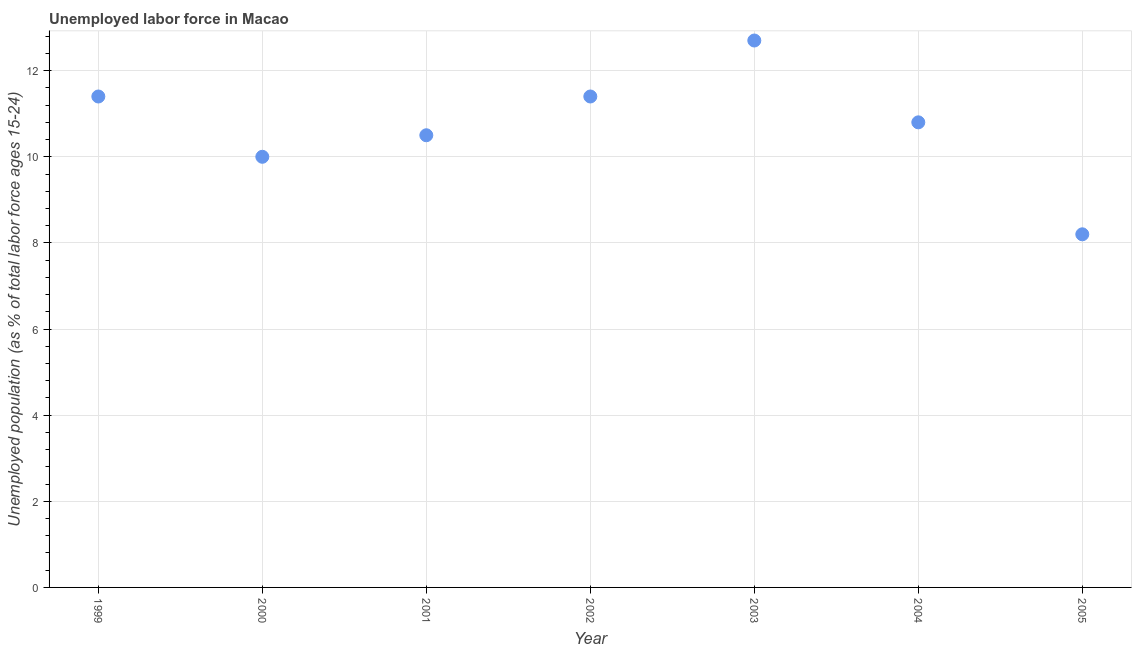What is the total unemployed youth population in 2003?
Offer a terse response. 12.7. Across all years, what is the maximum total unemployed youth population?
Give a very brief answer. 12.7. Across all years, what is the minimum total unemployed youth population?
Your response must be concise. 8.2. What is the sum of the total unemployed youth population?
Your answer should be compact. 75. What is the difference between the total unemployed youth population in 2001 and 2004?
Offer a terse response. -0.3. What is the average total unemployed youth population per year?
Give a very brief answer. 10.71. What is the median total unemployed youth population?
Offer a very short reply. 10.8. Do a majority of the years between 2005 and 2002 (inclusive) have total unemployed youth population greater than 1.2000000000000002 %?
Your answer should be compact. Yes. What is the ratio of the total unemployed youth population in 2003 to that in 2005?
Offer a terse response. 1.55. Is the total unemployed youth population in 1999 less than that in 2000?
Your answer should be compact. No. Is the difference between the total unemployed youth population in 2002 and 2003 greater than the difference between any two years?
Offer a terse response. No. What is the difference between the highest and the second highest total unemployed youth population?
Give a very brief answer. 1.3. Is the sum of the total unemployed youth population in 2000 and 2005 greater than the maximum total unemployed youth population across all years?
Offer a very short reply. Yes. What is the difference between the highest and the lowest total unemployed youth population?
Keep it short and to the point. 4.5. In how many years, is the total unemployed youth population greater than the average total unemployed youth population taken over all years?
Offer a terse response. 4. Does the total unemployed youth population monotonically increase over the years?
Your answer should be very brief. No. How many dotlines are there?
Make the answer very short. 1. What is the difference between two consecutive major ticks on the Y-axis?
Give a very brief answer. 2. Are the values on the major ticks of Y-axis written in scientific E-notation?
Provide a short and direct response. No. What is the title of the graph?
Your answer should be compact. Unemployed labor force in Macao. What is the label or title of the Y-axis?
Provide a short and direct response. Unemployed population (as % of total labor force ages 15-24). What is the Unemployed population (as % of total labor force ages 15-24) in 1999?
Keep it short and to the point. 11.4. What is the Unemployed population (as % of total labor force ages 15-24) in 2001?
Make the answer very short. 10.5. What is the Unemployed population (as % of total labor force ages 15-24) in 2002?
Provide a short and direct response. 11.4. What is the Unemployed population (as % of total labor force ages 15-24) in 2003?
Keep it short and to the point. 12.7. What is the Unemployed population (as % of total labor force ages 15-24) in 2004?
Your answer should be very brief. 10.8. What is the Unemployed population (as % of total labor force ages 15-24) in 2005?
Ensure brevity in your answer.  8.2. What is the difference between the Unemployed population (as % of total labor force ages 15-24) in 1999 and 2003?
Provide a succinct answer. -1.3. What is the difference between the Unemployed population (as % of total labor force ages 15-24) in 2000 and 2001?
Keep it short and to the point. -0.5. What is the difference between the Unemployed population (as % of total labor force ages 15-24) in 2000 and 2004?
Give a very brief answer. -0.8. What is the difference between the Unemployed population (as % of total labor force ages 15-24) in 2000 and 2005?
Your answer should be very brief. 1.8. What is the difference between the Unemployed population (as % of total labor force ages 15-24) in 2001 and 2002?
Provide a short and direct response. -0.9. What is the difference between the Unemployed population (as % of total labor force ages 15-24) in 2001 and 2005?
Your answer should be very brief. 2.3. What is the difference between the Unemployed population (as % of total labor force ages 15-24) in 2002 and 2003?
Provide a short and direct response. -1.3. What is the difference between the Unemployed population (as % of total labor force ages 15-24) in 2002 and 2005?
Offer a very short reply. 3.2. What is the difference between the Unemployed population (as % of total labor force ages 15-24) in 2003 and 2004?
Keep it short and to the point. 1.9. What is the difference between the Unemployed population (as % of total labor force ages 15-24) in 2003 and 2005?
Your answer should be very brief. 4.5. What is the difference between the Unemployed population (as % of total labor force ages 15-24) in 2004 and 2005?
Offer a very short reply. 2.6. What is the ratio of the Unemployed population (as % of total labor force ages 15-24) in 1999 to that in 2000?
Give a very brief answer. 1.14. What is the ratio of the Unemployed population (as % of total labor force ages 15-24) in 1999 to that in 2001?
Your answer should be very brief. 1.09. What is the ratio of the Unemployed population (as % of total labor force ages 15-24) in 1999 to that in 2003?
Keep it short and to the point. 0.9. What is the ratio of the Unemployed population (as % of total labor force ages 15-24) in 1999 to that in 2004?
Offer a terse response. 1.06. What is the ratio of the Unemployed population (as % of total labor force ages 15-24) in 1999 to that in 2005?
Your answer should be compact. 1.39. What is the ratio of the Unemployed population (as % of total labor force ages 15-24) in 2000 to that in 2002?
Keep it short and to the point. 0.88. What is the ratio of the Unemployed population (as % of total labor force ages 15-24) in 2000 to that in 2003?
Make the answer very short. 0.79. What is the ratio of the Unemployed population (as % of total labor force ages 15-24) in 2000 to that in 2004?
Ensure brevity in your answer.  0.93. What is the ratio of the Unemployed population (as % of total labor force ages 15-24) in 2000 to that in 2005?
Keep it short and to the point. 1.22. What is the ratio of the Unemployed population (as % of total labor force ages 15-24) in 2001 to that in 2002?
Provide a short and direct response. 0.92. What is the ratio of the Unemployed population (as % of total labor force ages 15-24) in 2001 to that in 2003?
Your answer should be compact. 0.83. What is the ratio of the Unemployed population (as % of total labor force ages 15-24) in 2001 to that in 2004?
Your answer should be very brief. 0.97. What is the ratio of the Unemployed population (as % of total labor force ages 15-24) in 2001 to that in 2005?
Ensure brevity in your answer.  1.28. What is the ratio of the Unemployed population (as % of total labor force ages 15-24) in 2002 to that in 2003?
Your response must be concise. 0.9. What is the ratio of the Unemployed population (as % of total labor force ages 15-24) in 2002 to that in 2004?
Your answer should be very brief. 1.06. What is the ratio of the Unemployed population (as % of total labor force ages 15-24) in 2002 to that in 2005?
Your response must be concise. 1.39. What is the ratio of the Unemployed population (as % of total labor force ages 15-24) in 2003 to that in 2004?
Give a very brief answer. 1.18. What is the ratio of the Unemployed population (as % of total labor force ages 15-24) in 2003 to that in 2005?
Keep it short and to the point. 1.55. What is the ratio of the Unemployed population (as % of total labor force ages 15-24) in 2004 to that in 2005?
Offer a very short reply. 1.32. 